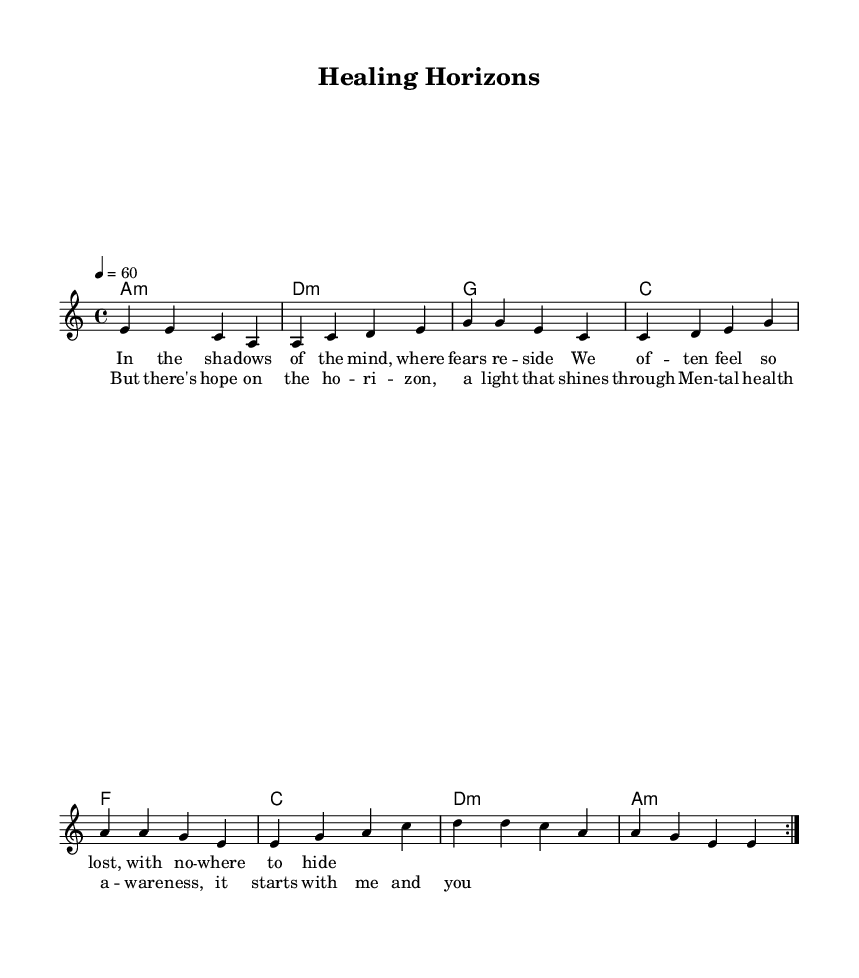What is the key signature of this music? The key signature shown in the music indicates that it is in A minor, which typically contains no sharps or flats. The presence of the A in the initial chord and in the melody confirms this.
Answer: A minor What is the time signature of this piece? The time signature is indicated at the beginning of the music, displaying a 4/4 format, which means there are four beats in each measure and each quarter note receives one beat.
Answer: 4/4 What is the tempo marking for this composition? The tempo marking states "4 = 60," which means that there should be a quarter note played at a speed of 60 beats per minute, indicating a slow pace suitable for a blues ballad.
Answer: 60 How many times is the verse repeated? The verse is indicated to be repeated using a volta marking in the melody section; it states that the section should be repeated two times, as shown in the notation.
Answer: 2 What is the emotional theme of the lyrics? The lyrics reflect themes of mental health awareness, as expressed through phrases indicating struggles and the presence of hope, illustrating the emotional weight typical of blues music.
Answer: Hope What chord is played in the first measure? The first measure of harmonies shows the chord labeled as "a:m," which indicates an A minor chord is played at the start of the piece, setting the mood typical for blues.
Answer: A minor What is the main focus of the chorus lyrics? The chorus lyrics emphasize the concept of hope and personal responsibility in mental health awareness, which is a key message of this piece. This reflects a characteristic blues theme of addressing struggles with optimism.
Answer: Mental health awareness 